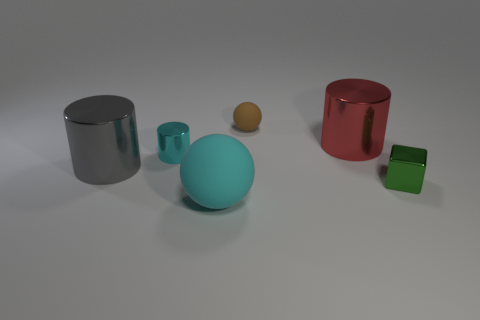Add 3 big red shiny cylinders. How many objects exist? 9 Subtract all balls. How many objects are left? 4 Add 3 metallic cylinders. How many metallic cylinders exist? 6 Subtract 1 cyan cylinders. How many objects are left? 5 Subtract all metal spheres. Subtract all green blocks. How many objects are left? 5 Add 5 small spheres. How many small spheres are left? 6 